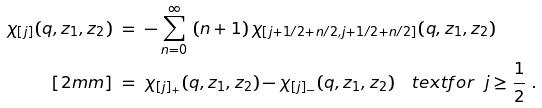Convert formula to latex. <formula><loc_0><loc_0><loc_500><loc_500>\chi _ { [ j ] } ( q , z _ { 1 } , z _ { 2 } ) & \ = \ - \sum _ { n = 0 } ^ { \infty } \ ( n + 1 ) \, \chi _ { [ j + 1 / 2 + n / 2 , j + 1 / 2 + n / 2 ] } ( q , z _ { 1 } , z _ { 2 } ) \\ [ 2 m m ] & \ = \ \chi _ { [ j ] _ { + } } ( q , z _ { 1 } , z _ { 2 } ) - \chi _ { [ j ] _ { - } } ( q , z _ { 1 } , z _ { 2 } ) \quad t e x t { f o r } \ \ j \geq \frac { 1 } { 2 } \ .</formula> 